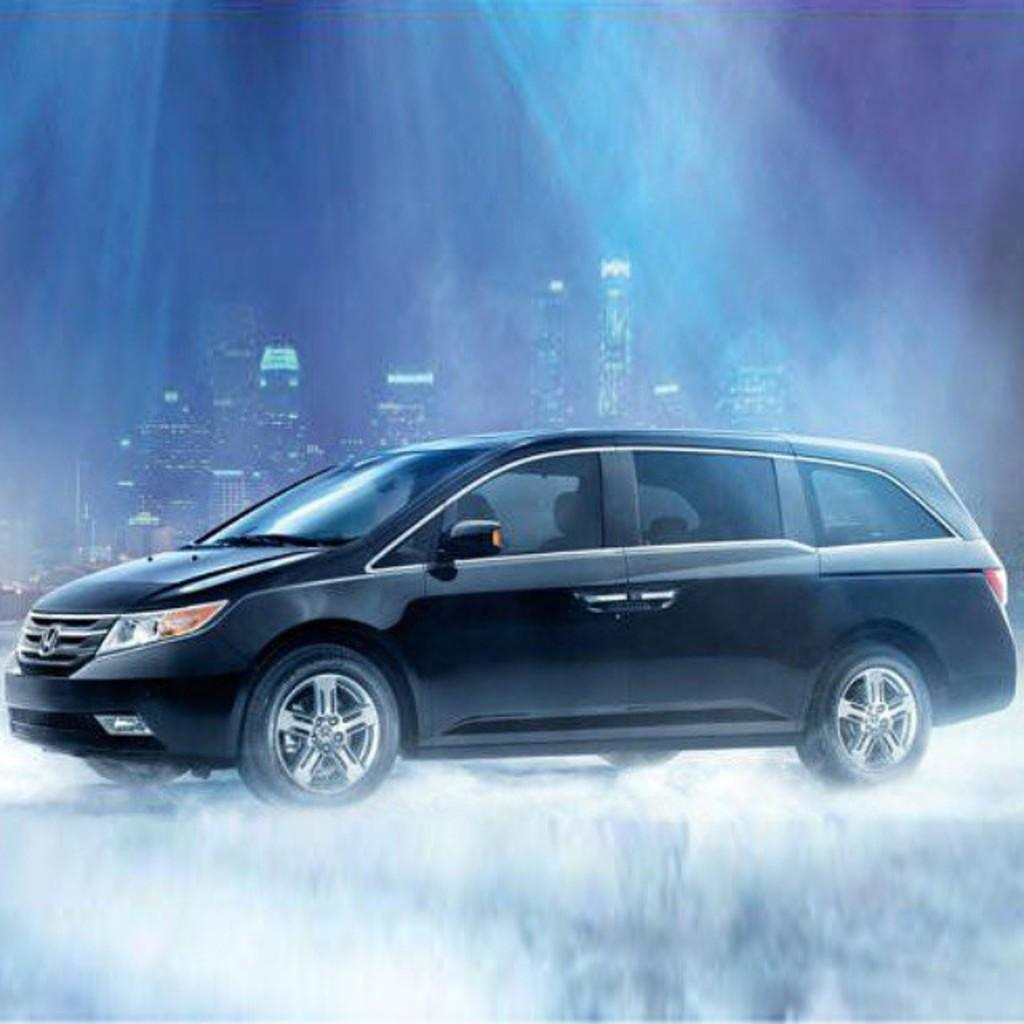What is the main subject in the middle of the image? There is a car in the middle of the image. What can be seen in the distance behind the car? There are buildings in the background of the image. Are there any additional features visible in the background? Yes, there are lights visible in the background of the image. How many sheep can be seen grazing near the car in the image? There are no sheep present in the image. What type of comb is being used by the car in the image? There is no comb visible in the image, as it is a photograph of a car and not a person or animal. 